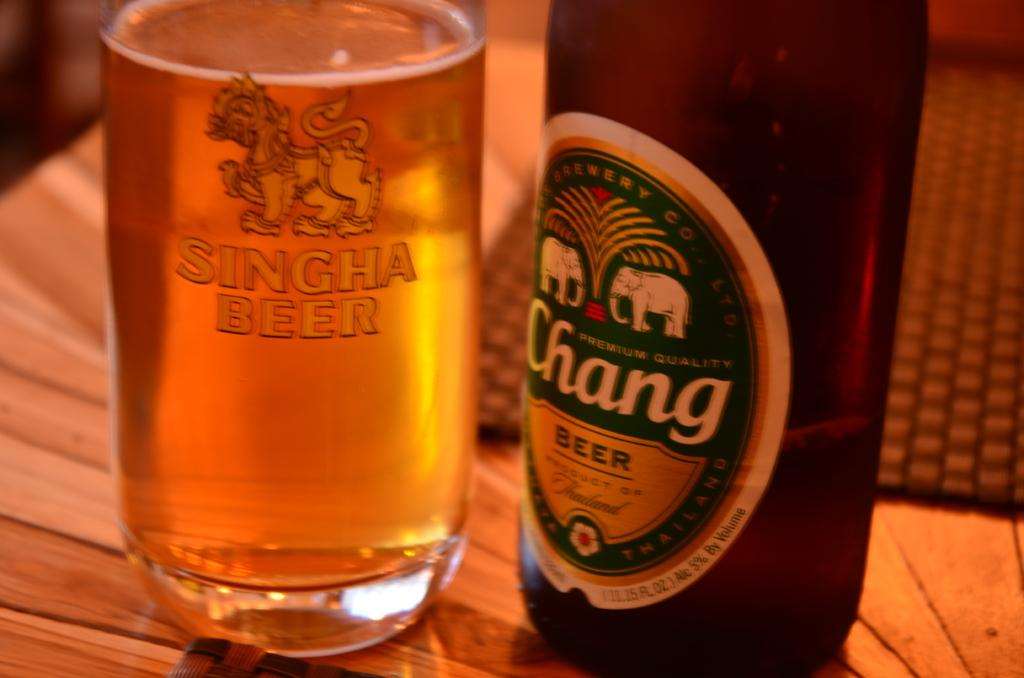Provide a one-sentence caption for the provided image. A bottle of Chang Beer with elephants on the bottle, and a glass filled with Chang beer. 